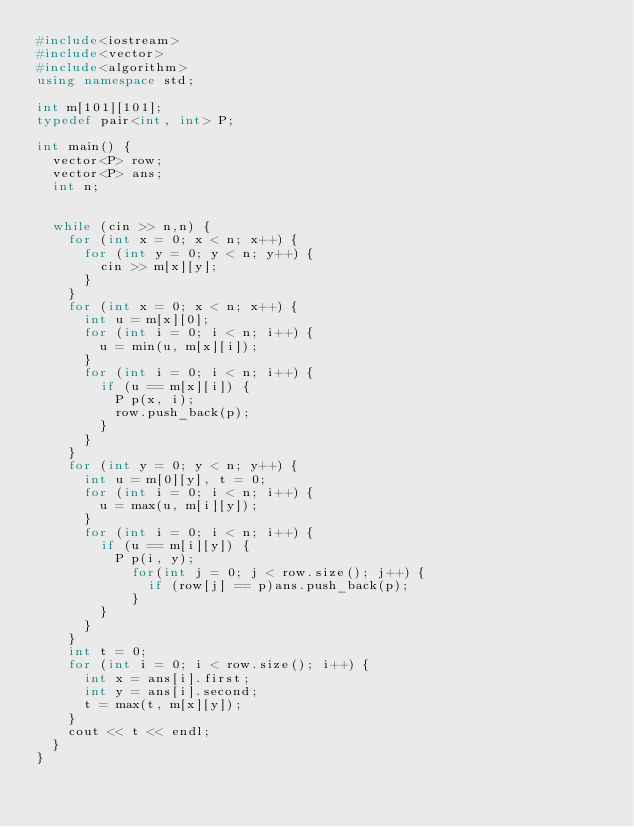<code> <loc_0><loc_0><loc_500><loc_500><_C++_>#include<iostream>
#include<vector>
#include<algorithm>
using namespace std;

int m[101][101];
typedef pair<int, int> P;

int main() {
	vector<P> row;
	vector<P> ans;
	int n;

	
	while (cin >> n,n) {
		for (int x = 0; x < n; x++) {
			for (int y = 0; y < n; y++) {
				cin >> m[x][y];
			}
		}
		for (int x = 0; x < n; x++) {
			int u = m[x][0];
			for (int i = 0; i < n; i++) {
				u = min(u, m[x][i]);
			}
			for (int i = 0; i < n; i++) {
				if (u == m[x][i]) {
					P p(x, i);
					row.push_back(p);
				}
			}
		}
		for (int y = 0; y < n; y++) {
			int u = m[0][y], t = 0;
			for (int i = 0; i < n; i++) {
				u = max(u, m[i][y]);
			}
			for (int i = 0; i < n; i++) {
				if (u == m[i][y]) {
					P p(i, y);
						for(int j = 0; j < row.size(); j++) {
							if (row[j] == p)ans.push_back(p);
						}
				}
			}
		}
		int t = 0;
		for (int i = 0; i < row.size(); i++) {
			int x = ans[i].first;
			int y = ans[i].second;
			t = max(t, m[x][y]);
		}
		cout << t << endl;
	}
}</code> 